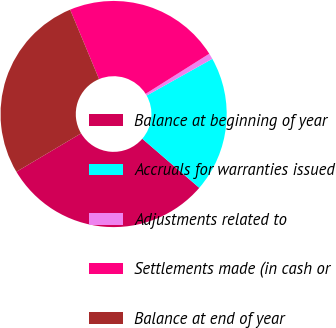Convert chart to OTSL. <chart><loc_0><loc_0><loc_500><loc_500><pie_chart><fcel>Balance at beginning of year<fcel>Accruals for warranties issued<fcel>Adjustments related to<fcel>Settlements made (in cash or<fcel>Balance at end of year<nl><fcel>30.15%<fcel>19.44%<fcel>0.83%<fcel>22.33%<fcel>27.25%<nl></chart> 